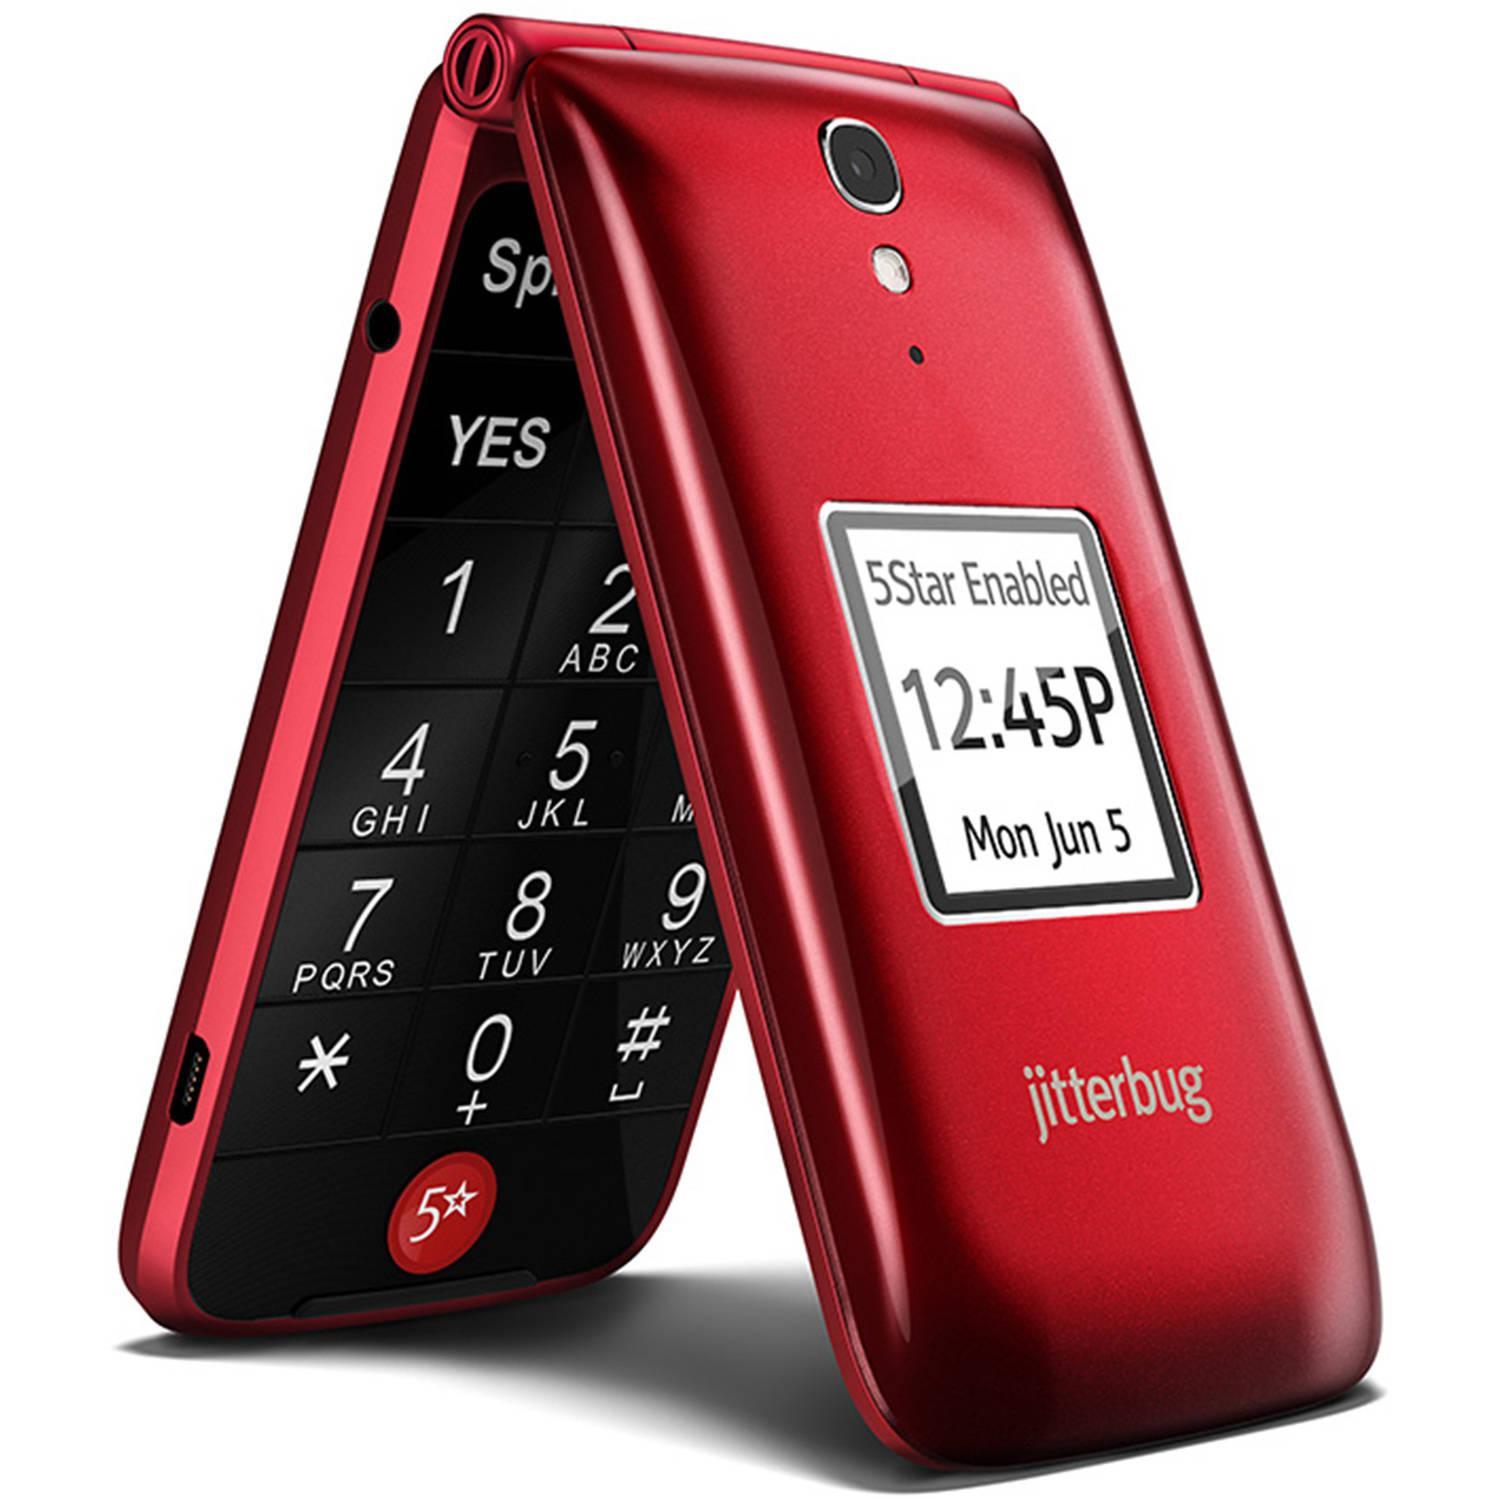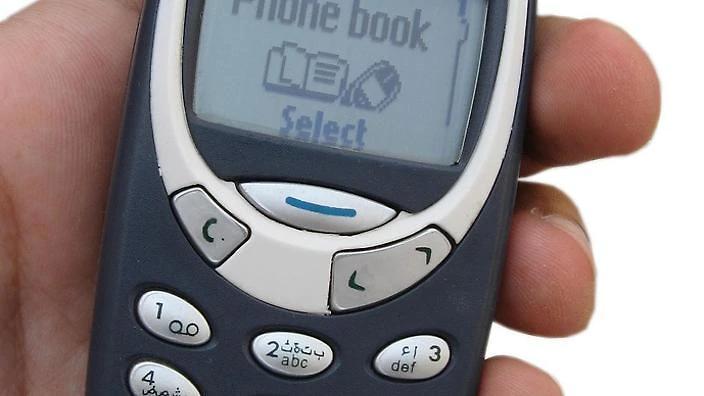The first image is the image on the left, the second image is the image on the right. Evaluate the accuracy of this statement regarding the images: "In one image there is a red flip phone and in the other image there is a hand holding a grey and black phone.". Is it true? Answer yes or no. Yes. The first image is the image on the left, the second image is the image on the right. Evaluate the accuracy of this statement regarding the images: "An image shows a gray-haired man with one hand on his chin and a phone on the left.". Is it true? Answer yes or no. No. 